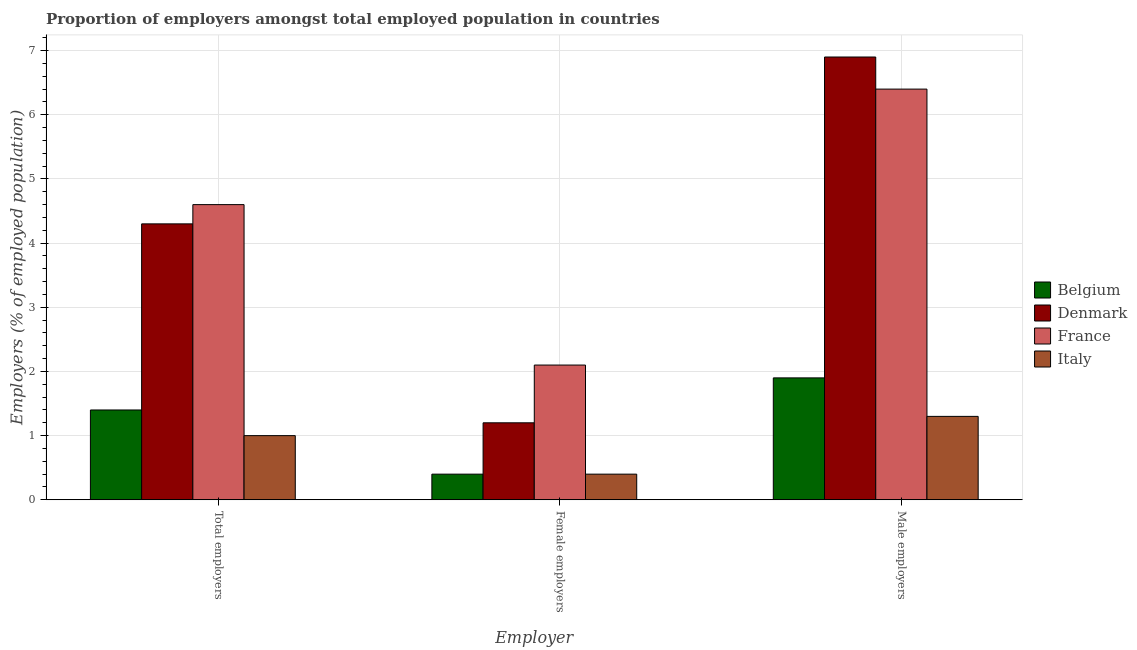How many different coloured bars are there?
Provide a succinct answer. 4. How many groups of bars are there?
Provide a succinct answer. 3. Are the number of bars per tick equal to the number of legend labels?
Offer a terse response. Yes. Are the number of bars on each tick of the X-axis equal?
Make the answer very short. Yes. How many bars are there on the 3rd tick from the left?
Provide a short and direct response. 4. How many bars are there on the 2nd tick from the right?
Ensure brevity in your answer.  4. What is the label of the 3rd group of bars from the left?
Provide a succinct answer. Male employers. What is the percentage of male employers in Belgium?
Provide a succinct answer. 1.9. Across all countries, what is the maximum percentage of male employers?
Give a very brief answer. 6.9. Across all countries, what is the minimum percentage of male employers?
Your answer should be compact. 1.3. In which country was the percentage of female employers maximum?
Ensure brevity in your answer.  France. In which country was the percentage of male employers minimum?
Your answer should be very brief. Italy. What is the total percentage of total employers in the graph?
Your response must be concise. 11.3. What is the difference between the percentage of male employers in Denmark and that in France?
Provide a short and direct response. 0.5. What is the difference between the percentage of total employers in Italy and the percentage of female employers in France?
Your response must be concise. -1.1. What is the average percentage of male employers per country?
Your answer should be very brief. 4.13. What is the difference between the percentage of male employers and percentage of total employers in Italy?
Provide a short and direct response. 0.3. In how many countries, is the percentage of total employers greater than 1.2 %?
Provide a short and direct response. 3. What is the ratio of the percentage of female employers in France to that in Belgium?
Your answer should be compact. 5.25. Is the percentage of female employers in Belgium less than that in Denmark?
Your answer should be compact. Yes. Is the difference between the percentage of female employers in France and Belgium greater than the difference between the percentage of total employers in France and Belgium?
Keep it short and to the point. No. What is the difference between the highest and the lowest percentage of female employers?
Ensure brevity in your answer.  1.7. In how many countries, is the percentage of female employers greater than the average percentage of female employers taken over all countries?
Offer a terse response. 2. Is the sum of the percentage of male employers in Belgium and Italy greater than the maximum percentage of total employers across all countries?
Provide a short and direct response. No. What does the 2nd bar from the right in Male employers represents?
Offer a terse response. France. How many countries are there in the graph?
Offer a very short reply. 4. What is the difference between two consecutive major ticks on the Y-axis?
Your response must be concise. 1. Does the graph contain any zero values?
Your response must be concise. No. What is the title of the graph?
Offer a very short reply. Proportion of employers amongst total employed population in countries. Does "Sierra Leone" appear as one of the legend labels in the graph?
Offer a terse response. No. What is the label or title of the X-axis?
Offer a very short reply. Employer. What is the label or title of the Y-axis?
Offer a very short reply. Employers (% of employed population). What is the Employers (% of employed population) of Belgium in Total employers?
Ensure brevity in your answer.  1.4. What is the Employers (% of employed population) in Denmark in Total employers?
Offer a terse response. 4.3. What is the Employers (% of employed population) in France in Total employers?
Offer a terse response. 4.6. What is the Employers (% of employed population) in Italy in Total employers?
Your response must be concise. 1. What is the Employers (% of employed population) of Belgium in Female employers?
Offer a terse response. 0.4. What is the Employers (% of employed population) of Denmark in Female employers?
Provide a succinct answer. 1.2. What is the Employers (% of employed population) of France in Female employers?
Your answer should be very brief. 2.1. What is the Employers (% of employed population) in Italy in Female employers?
Give a very brief answer. 0.4. What is the Employers (% of employed population) of Belgium in Male employers?
Keep it short and to the point. 1.9. What is the Employers (% of employed population) in Denmark in Male employers?
Keep it short and to the point. 6.9. What is the Employers (% of employed population) of France in Male employers?
Give a very brief answer. 6.4. What is the Employers (% of employed population) of Italy in Male employers?
Offer a terse response. 1.3. Across all Employer, what is the maximum Employers (% of employed population) in Belgium?
Your answer should be compact. 1.9. Across all Employer, what is the maximum Employers (% of employed population) of Denmark?
Offer a terse response. 6.9. Across all Employer, what is the maximum Employers (% of employed population) in France?
Your answer should be very brief. 6.4. Across all Employer, what is the maximum Employers (% of employed population) in Italy?
Provide a short and direct response. 1.3. Across all Employer, what is the minimum Employers (% of employed population) in Belgium?
Provide a short and direct response. 0.4. Across all Employer, what is the minimum Employers (% of employed population) of Denmark?
Offer a very short reply. 1.2. Across all Employer, what is the minimum Employers (% of employed population) of France?
Provide a succinct answer. 2.1. Across all Employer, what is the minimum Employers (% of employed population) in Italy?
Make the answer very short. 0.4. What is the difference between the Employers (% of employed population) in Belgium in Total employers and that in Female employers?
Provide a short and direct response. 1. What is the difference between the Employers (% of employed population) of Denmark in Total employers and that in Female employers?
Offer a terse response. 3.1. What is the difference between the Employers (% of employed population) of France in Total employers and that in Female employers?
Ensure brevity in your answer.  2.5. What is the difference between the Employers (% of employed population) in Italy in Total employers and that in Female employers?
Your answer should be compact. 0.6. What is the difference between the Employers (% of employed population) of Italy in Total employers and that in Male employers?
Give a very brief answer. -0.3. What is the difference between the Employers (% of employed population) of Belgium in Female employers and that in Male employers?
Provide a succinct answer. -1.5. What is the difference between the Employers (% of employed population) in Denmark in Female employers and that in Male employers?
Provide a short and direct response. -5.7. What is the difference between the Employers (% of employed population) of Belgium in Total employers and the Employers (% of employed population) of Denmark in Female employers?
Offer a very short reply. 0.2. What is the difference between the Employers (% of employed population) of Belgium in Total employers and the Employers (% of employed population) of Italy in Female employers?
Offer a very short reply. 1. What is the difference between the Employers (% of employed population) in Denmark in Total employers and the Employers (% of employed population) in France in Female employers?
Give a very brief answer. 2.2. What is the difference between the Employers (% of employed population) in Denmark in Total employers and the Employers (% of employed population) in Italy in Female employers?
Your answer should be compact. 3.9. What is the difference between the Employers (% of employed population) of France in Total employers and the Employers (% of employed population) of Italy in Female employers?
Keep it short and to the point. 4.2. What is the difference between the Employers (% of employed population) of Belgium in Total employers and the Employers (% of employed population) of Italy in Male employers?
Your answer should be very brief. 0.1. What is the difference between the Employers (% of employed population) of Denmark in Total employers and the Employers (% of employed population) of France in Male employers?
Give a very brief answer. -2.1. What is the difference between the Employers (% of employed population) of Denmark in Total employers and the Employers (% of employed population) of Italy in Male employers?
Offer a terse response. 3. What is the difference between the Employers (% of employed population) of Belgium in Female employers and the Employers (% of employed population) of Denmark in Male employers?
Provide a short and direct response. -6.5. What is the difference between the Employers (% of employed population) in Belgium in Female employers and the Employers (% of employed population) in France in Male employers?
Keep it short and to the point. -6. What is the difference between the Employers (% of employed population) in France in Female employers and the Employers (% of employed population) in Italy in Male employers?
Offer a very short reply. 0.8. What is the average Employers (% of employed population) in Belgium per Employer?
Offer a terse response. 1.23. What is the average Employers (% of employed population) in Denmark per Employer?
Offer a terse response. 4.13. What is the average Employers (% of employed population) in France per Employer?
Your response must be concise. 4.37. What is the average Employers (% of employed population) of Italy per Employer?
Offer a terse response. 0.9. What is the difference between the Employers (% of employed population) of Belgium and Employers (% of employed population) of Denmark in Total employers?
Your answer should be very brief. -2.9. What is the difference between the Employers (% of employed population) in Belgium and Employers (% of employed population) in France in Total employers?
Offer a terse response. -3.2. What is the difference between the Employers (% of employed population) in Belgium and Employers (% of employed population) in Italy in Total employers?
Give a very brief answer. 0.4. What is the difference between the Employers (% of employed population) in Denmark and Employers (% of employed population) in France in Total employers?
Provide a short and direct response. -0.3. What is the difference between the Employers (% of employed population) in Denmark and Employers (% of employed population) in Italy in Total employers?
Provide a succinct answer. 3.3. What is the difference between the Employers (% of employed population) of France and Employers (% of employed population) of Italy in Total employers?
Provide a short and direct response. 3.6. What is the difference between the Employers (% of employed population) in Belgium and Employers (% of employed population) in France in Female employers?
Give a very brief answer. -1.7. What is the difference between the Employers (% of employed population) of Denmark and Employers (% of employed population) of Italy in Female employers?
Provide a short and direct response. 0.8. What is the difference between the Employers (% of employed population) in Belgium and Employers (% of employed population) in France in Male employers?
Offer a very short reply. -4.5. What is the difference between the Employers (% of employed population) of Belgium and Employers (% of employed population) of Italy in Male employers?
Provide a succinct answer. 0.6. What is the difference between the Employers (% of employed population) in Denmark and Employers (% of employed population) in France in Male employers?
Provide a short and direct response. 0.5. What is the difference between the Employers (% of employed population) in Denmark and Employers (% of employed population) in Italy in Male employers?
Ensure brevity in your answer.  5.6. What is the difference between the Employers (% of employed population) in France and Employers (% of employed population) in Italy in Male employers?
Make the answer very short. 5.1. What is the ratio of the Employers (% of employed population) of Denmark in Total employers to that in Female employers?
Your answer should be compact. 3.58. What is the ratio of the Employers (% of employed population) in France in Total employers to that in Female employers?
Give a very brief answer. 2.19. What is the ratio of the Employers (% of employed population) of Belgium in Total employers to that in Male employers?
Your response must be concise. 0.74. What is the ratio of the Employers (% of employed population) in Denmark in Total employers to that in Male employers?
Provide a succinct answer. 0.62. What is the ratio of the Employers (% of employed population) of France in Total employers to that in Male employers?
Provide a short and direct response. 0.72. What is the ratio of the Employers (% of employed population) in Italy in Total employers to that in Male employers?
Make the answer very short. 0.77. What is the ratio of the Employers (% of employed population) in Belgium in Female employers to that in Male employers?
Ensure brevity in your answer.  0.21. What is the ratio of the Employers (% of employed population) in Denmark in Female employers to that in Male employers?
Your answer should be very brief. 0.17. What is the ratio of the Employers (% of employed population) in France in Female employers to that in Male employers?
Provide a short and direct response. 0.33. What is the ratio of the Employers (% of employed population) of Italy in Female employers to that in Male employers?
Your response must be concise. 0.31. What is the difference between the highest and the second highest Employers (% of employed population) in France?
Provide a succinct answer. 1.8. What is the difference between the highest and the second highest Employers (% of employed population) in Italy?
Provide a succinct answer. 0.3. What is the difference between the highest and the lowest Employers (% of employed population) of Belgium?
Your response must be concise. 1.5. What is the difference between the highest and the lowest Employers (% of employed population) in Denmark?
Provide a succinct answer. 5.7. What is the difference between the highest and the lowest Employers (% of employed population) in France?
Ensure brevity in your answer.  4.3. What is the difference between the highest and the lowest Employers (% of employed population) of Italy?
Make the answer very short. 0.9. 